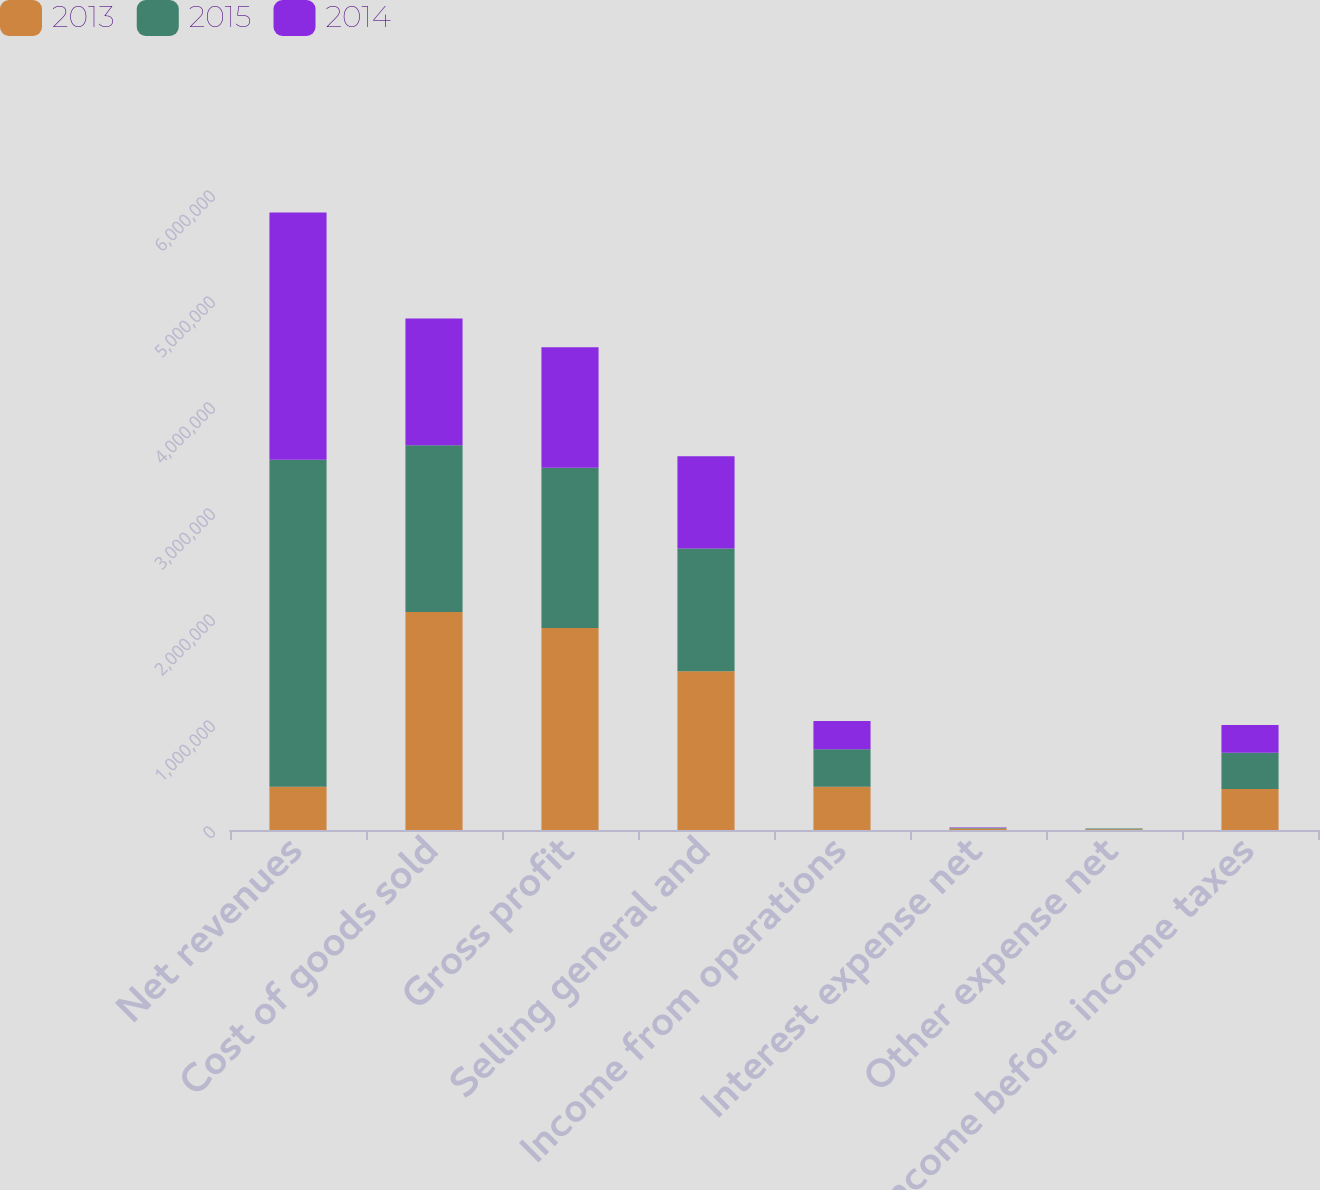Convert chart to OTSL. <chart><loc_0><loc_0><loc_500><loc_500><stacked_bar_chart><ecel><fcel>Net revenues<fcel>Cost of goods sold<fcel>Gross profit<fcel>Selling general and<fcel>Income from operations<fcel>Interest expense net<fcel>Other expense net<fcel>Income before income taxes<nl><fcel>2013<fcel>408547<fcel>2.05777e+06<fcel>1.90555e+06<fcel>1.497e+06<fcel>408547<fcel>14628<fcel>7234<fcel>386685<nl><fcel>2015<fcel>3.08437e+06<fcel>1.57216e+06<fcel>1.51221e+06<fcel>1.15825e+06<fcel>353955<fcel>5335<fcel>6410<fcel>342210<nl><fcel>2014<fcel>2.33205e+06<fcel>1.19538e+06<fcel>1.13667e+06<fcel>871572<fcel>265098<fcel>2933<fcel>1172<fcel>260993<nl></chart> 